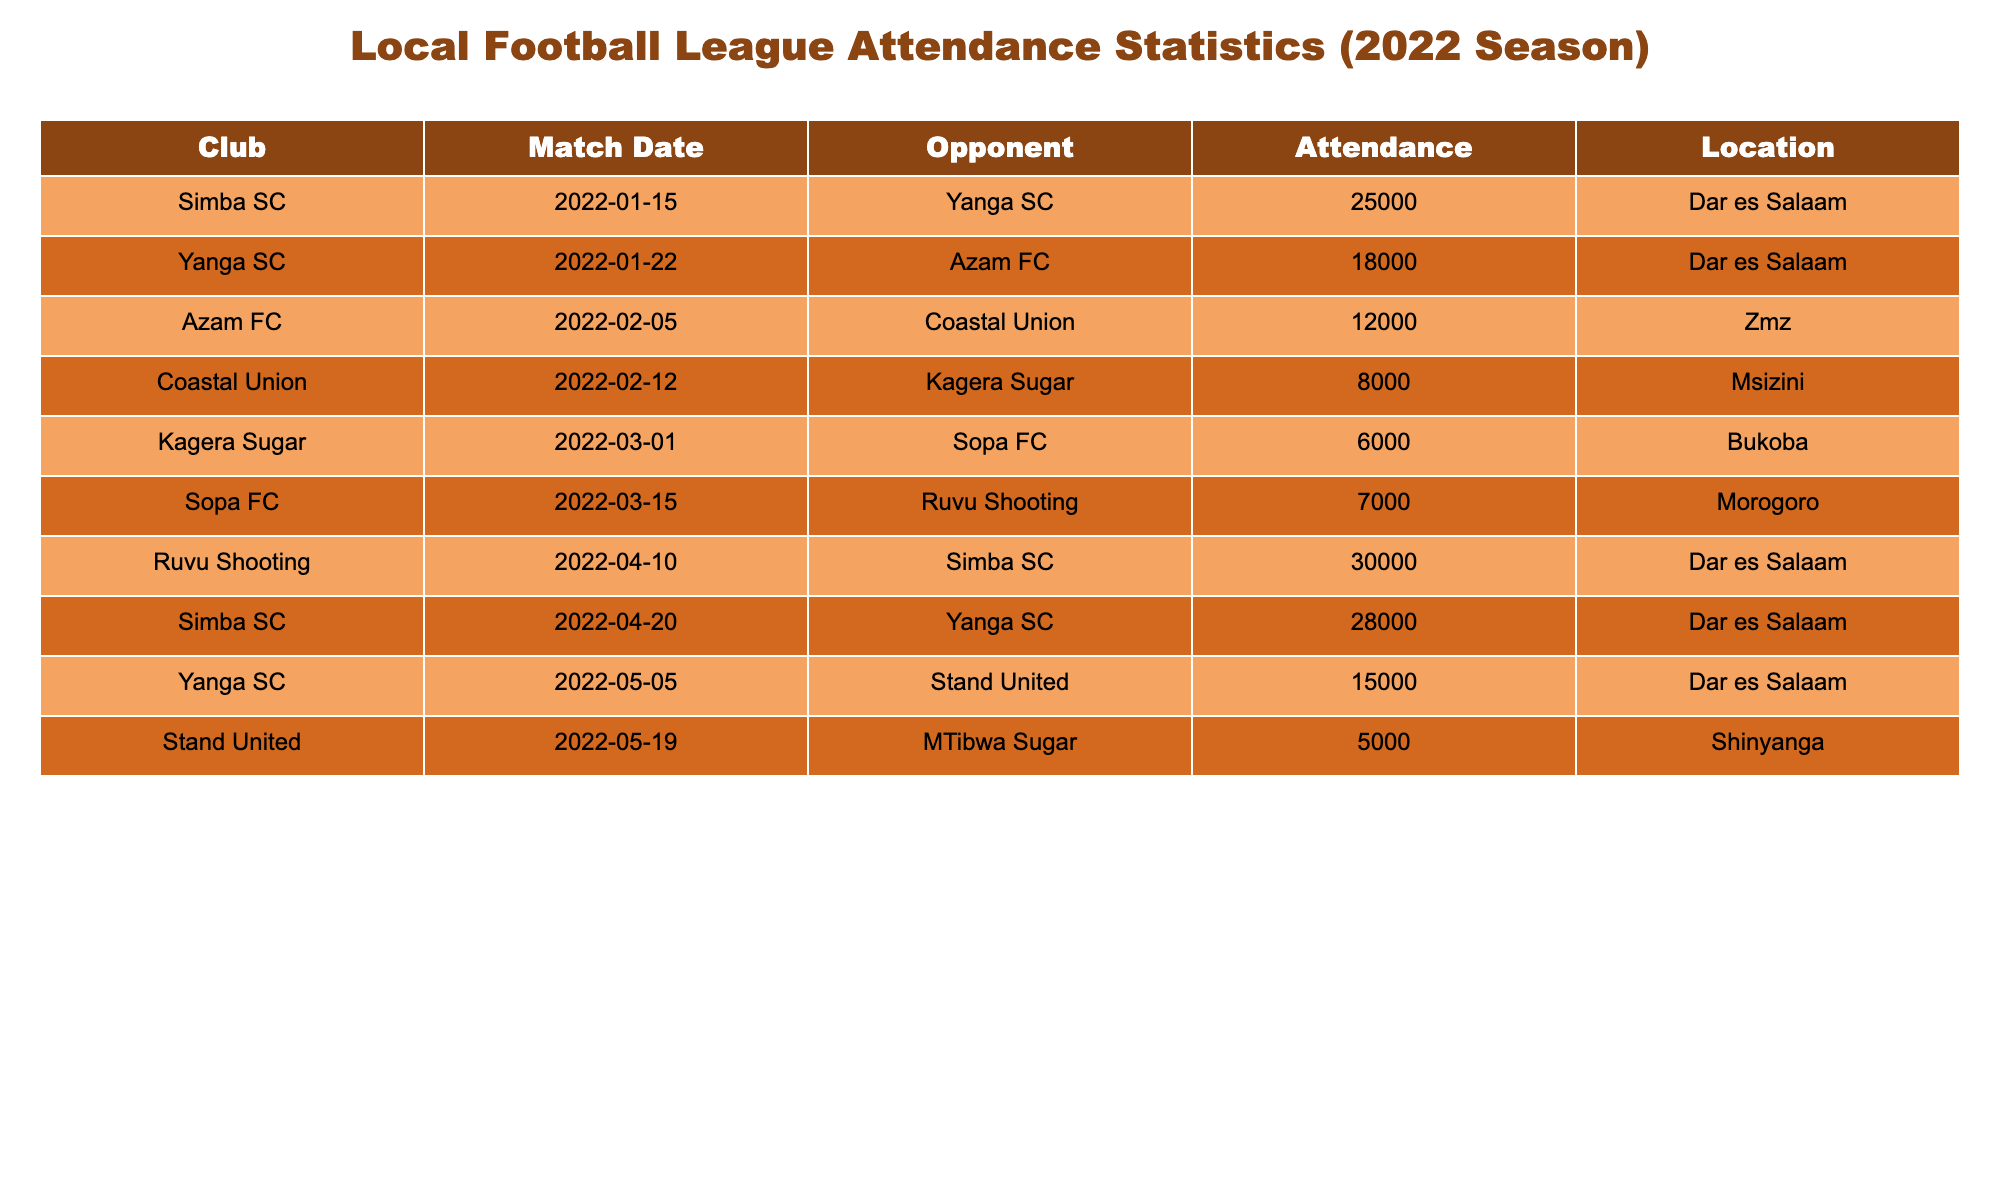What was the highest attendance recorded in a match? The highest attendance can be found by looking at the "Attendance" column in the table. The largest number present is 30000 for the match between Ruvu Shooting and Simba SC on 2022-04-10.
Answer: 30000 Which club had the lowest match attendance? We can identify the club with the lowest attendance by examining the "Attendance" column. The lowest attendance is 5000, which belongs to Stand United against MTibwa Sugar on 2022-05-19.
Answer: Stand United What is the total attendance for all matches played in Dar es Salaam? To find the total attendance for matches held in Dar es Salaam, we sum the "Attendance" values for those specific matches: 25000 (Simba vs Yanga) + 18000 (Yanga vs Azam) + 30000 (Ruvu vs Simba) + 28000 (Simba vs Yanga) + 15000 (Yanga vs Stand) = 116000.
Answer: 116000 Did Kagera Sugar ever have an attendance of over 7000? By reviewing the attendance figures, we see that Kagera Sugar had an attendance of 6000 in their match against Sopa FC, which is below 7000. Therefore, Kagera Sugar never had an attendance over 7000 in the given data.
Answer: No What is the average attendance for matches played by Yanga SC? To calculate the average attendance for Yanga SC matches, first identify the relevant attendance numbers: 25000 against Simba, 18000 against Azam, 15000 against Stand. The sum is 25000 + 18000 + 15000 = 58000. There are 3 matches, so the average is 58000 divided by 3, which equals 19333.33.
Answer: 19333.33 